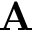Convert formula to latex. <formula><loc_0><loc_0><loc_500><loc_500>{ A }</formula> 